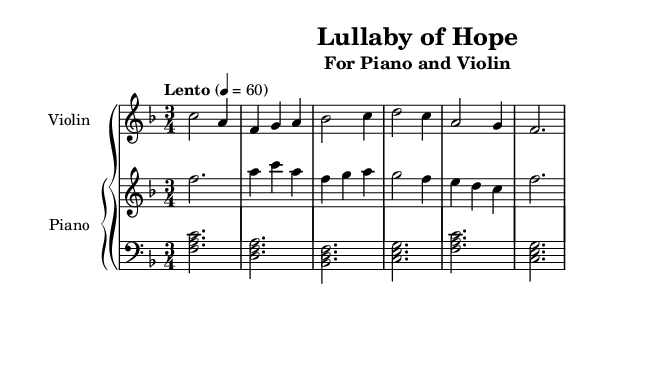What is the key signature of this music? The key signature appears at the beginning of the staff, indicating F major, which has one flat (B flat).
Answer: F major What is the time signature of this music? The time signature is displayed at the start of the sheet music, showing 3/4, indicating three beats per measure.
Answer: 3/4 What is the tempo marking for this piece? The tempo marking is located above the staff and reads "Lento", indicating a slow pace, along with a metronome marking of 60 beats per minute.
Answer: Lento How many measures does the piece contain? Counting the measures in the score from the beginning to the end, there are a total of 8 measures.
Answer: 8 What instruments are featured in this music? The title header states that the music is arranged for piano and violin, which identifies the instruments used.
Answer: Piano and Violin What is the last note played in the right hand part? Looking to the end of the right hand staff, the last note is an F, which is the final note in the sequence.
Answer: F What is the texture of the left hand in this piece? The left hand part includes chords throughout, creating a harmonic texture that supports the melody.
Answer: Chords 